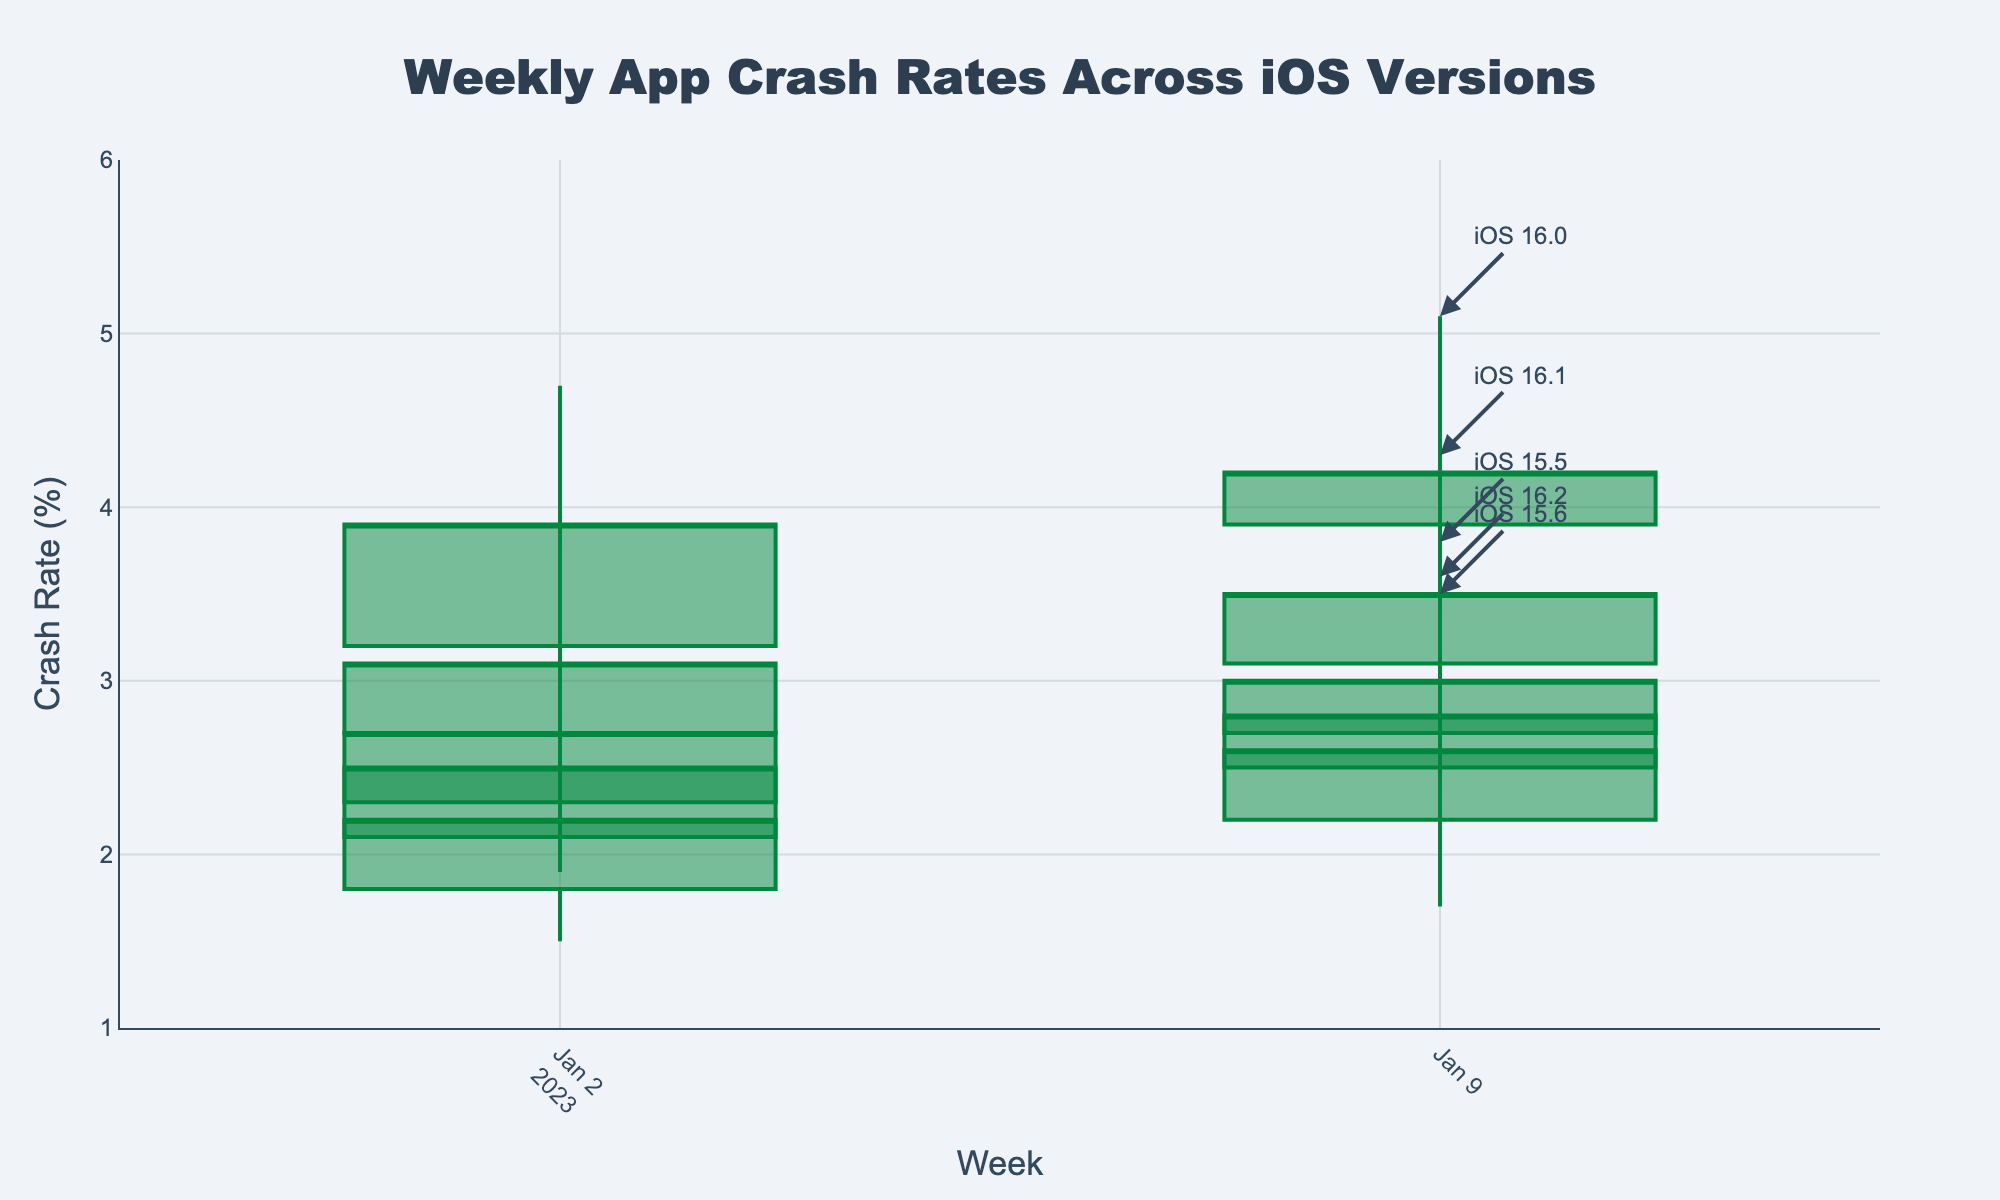What is the highest crash rate observed in the figure and in which iOS version? The highest crash rate can be observed by looking at the maximum (high) values of the OHLC bars. The peak is at 5.1% for iOS 16.0 during the second week.
Answer: 5.1%, iOS 16.0 What is the span of weeks covered in this chart? Look at the x-axis labels which indicate the range of weeks plotted. The span of weeks covers 2023-W01 to 2023-W02 for each iOS version.
Answer: 2023-W01 to 2023-W02 Which iOS version shows the lowest crash rate and in which week? To identify the lowest crash rate, one must note the minimum (low) values on the OHLC bars. The lowest is 1.5% under iOS 15.6 during the first week.
Answer: 1.5%, iOS 15.6, week 2023-W01 How do the crash rates for iOS 16.2 change from the first to the second week? Observe the OHLC bars for iOS 16.2 and track changes. In the first week, the closing crash rate increases from 2.7% to 3.0% in the second week.
Answer: From 2.7% to 3.0% Comparing iOS 15.5 and iOS 16.1, which has more stable crash rates in 2023-W02? Stability can be indicated by smaller differences between the high and low values. For iOS 15.5, the high is 3.2% and the low is 2.0%, a range of 1.2%. For iOS 16.1, the high is 4.3% and the low is 2.6%, a range of 1.7%. Thus, iOS 15.5 is more stable.
Answer: iOS 15.5 What trend can be observed in the crash rates for iOS 16.0 over the two weeks? The closing rate and high values for iOS 16.0 increase from week 2023-W01 to 2023-W02, indicating an upward trend in crash rates.
Answer: Upward trend Which iOS version shows the highest volatility in crash rates for 2023-W01? Volatility can be inferred from the range (high-low) within a week. For 2023-W01, iOS 16.0 has the highest range between 4.7% and 2.8%, a difference of 1.9%.
Answer: iOS 16.0 What's the average high crash rate for all iOS versions during 2023-W01? Calculate the average of the high crash rates for all iOS versions during the first week by summing the high rates and dividing by the count. (3.8 + 2.9 + 4.7 + 3.9 + 3.2) / 5 = 3.7%
Answer: 3.7% 